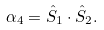Convert formula to latex. <formula><loc_0><loc_0><loc_500><loc_500>\alpha _ { 4 } = { \hat { S } } _ { 1 } \cdot { \hat { S } } _ { 2 } .</formula> 